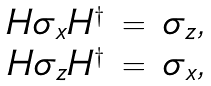<formula> <loc_0><loc_0><loc_500><loc_500>\begin{array} { r c l } H \sigma _ { x } H ^ { \dagger } & = & \sigma _ { z } , \\ H \sigma _ { z } H ^ { \dagger } & = & \sigma _ { x } , \end{array}</formula> 